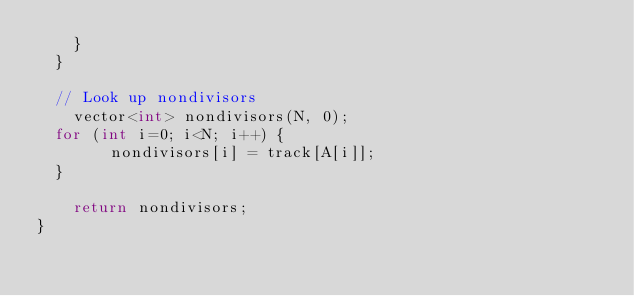<code> <loc_0><loc_0><loc_500><loc_500><_C++_>		}
	}

	// Look up nondivisors
    vector<int> nondivisors(N, 0);
	for (int i=0; i<N; i++) {
        nondivisors[i] = track[A[i]];
	}

    return nondivisors;
}
</code> 